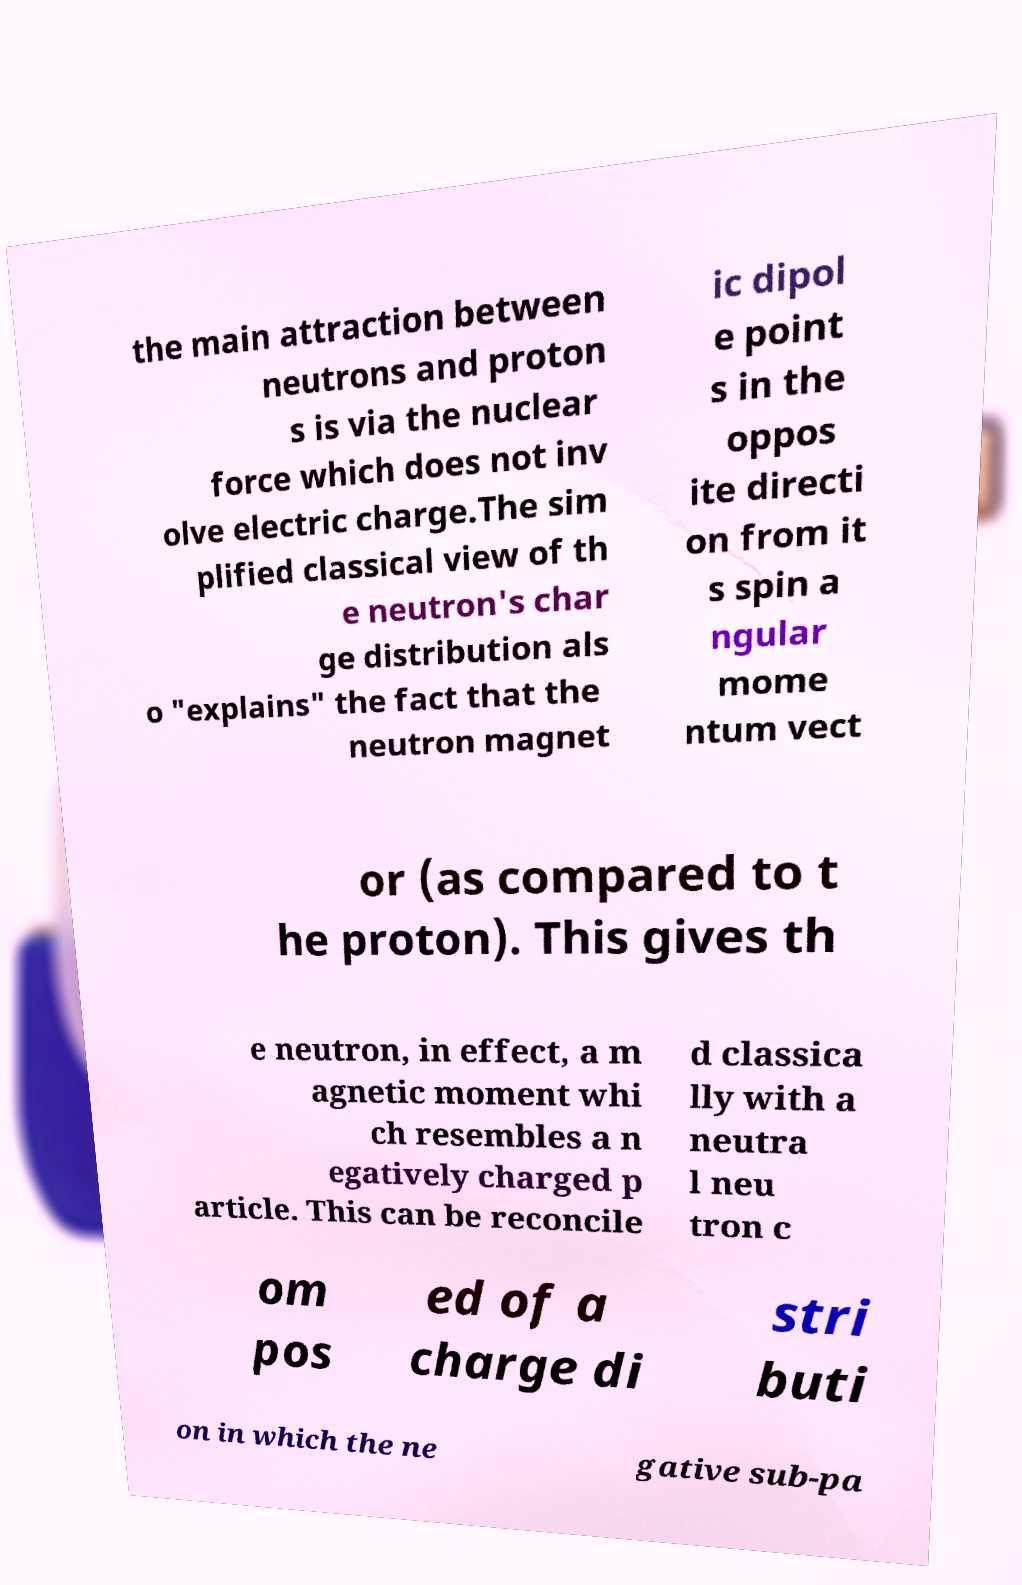Can you accurately transcribe the text from the provided image for me? the main attraction between neutrons and proton s is via the nuclear force which does not inv olve electric charge.The sim plified classical view of th e neutron's char ge distribution als o "explains" the fact that the neutron magnet ic dipol e point s in the oppos ite directi on from it s spin a ngular mome ntum vect or (as compared to t he proton). This gives th e neutron, in effect, a m agnetic moment whi ch resembles a n egatively charged p article. This can be reconcile d classica lly with a neutra l neu tron c om pos ed of a charge di stri buti on in which the ne gative sub-pa 